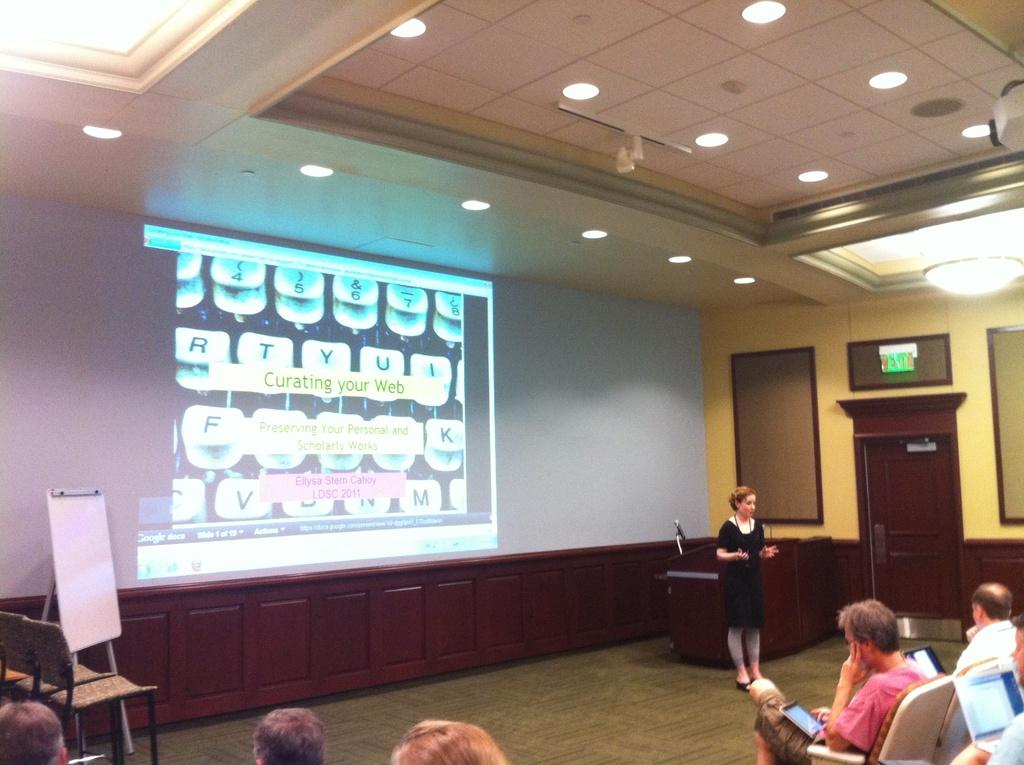<image>
Write a terse but informative summary of the picture. a conference room and a screen in front saying Curating your Web Preserving your personal and scholarly works Ellysa Stern Cahoy LDSC 2011. 